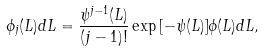<formula> <loc_0><loc_0><loc_500><loc_500>\phi _ { j } ( L ) d L = \frac { \psi ^ { j - 1 } ( L ) } { ( j - 1 ) ! } \exp { [ - \psi ( L ) ] } \phi ( L ) d L ,</formula> 